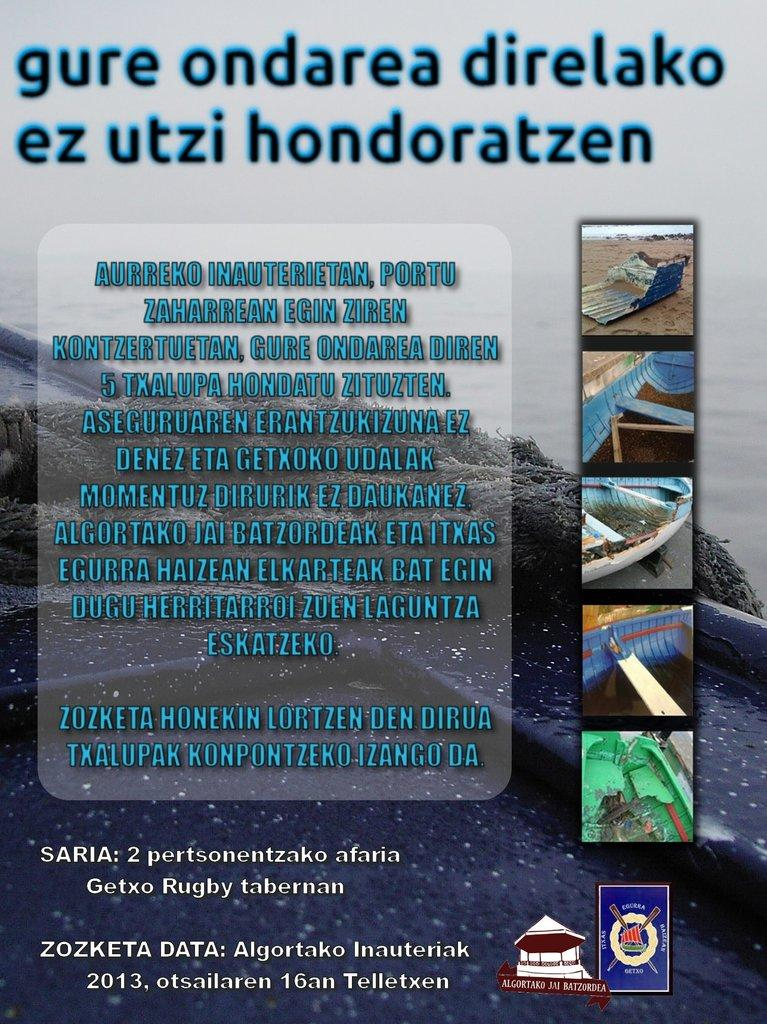<image>
Write a terse but informative summary of the picture. A poster that says gure ondarea direlako ez utzi hondoratzen. 